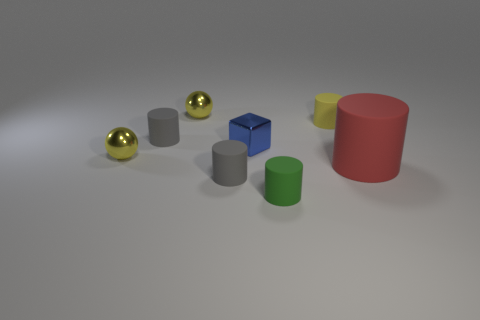What number of things are matte objects that are in front of the big red thing or big matte things? There are two matte cylinders in front of the big red cylinder, and one big matte cube. Counting all, there are three big or front-positioned matte objects. 